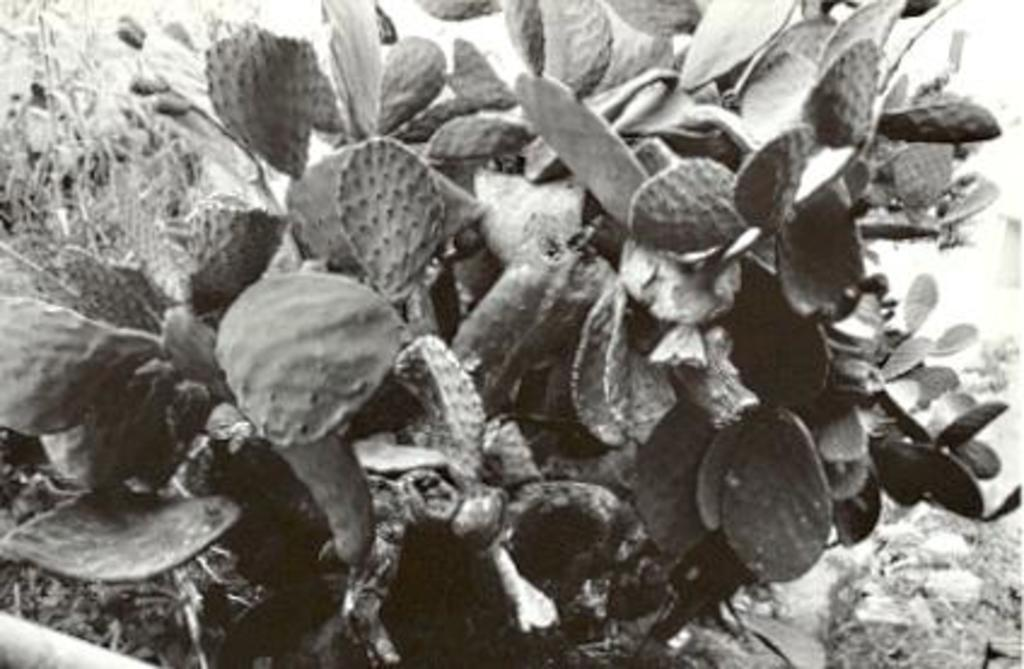What type of living organism can be seen in the image? There is a plant in the image. What can be found in the bottom right corner of the image? There are stones in the bottom right corner of the image. How many cherries are hanging from the plant in the image? There are no cherries present in the image; it only features a plant and stones. What type of society is depicted in the image? There is no society depicted in the image; it only features a plant and stones. 